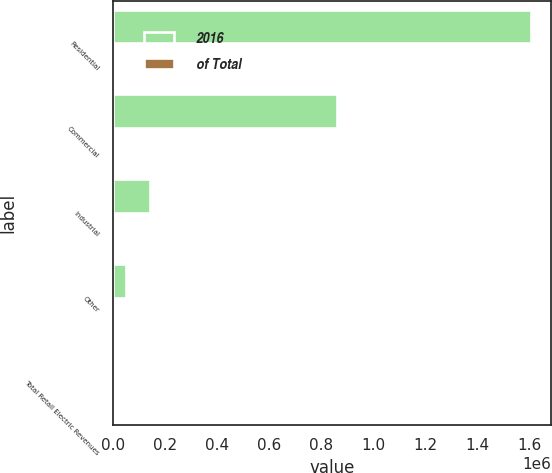Convert chart to OTSL. <chart><loc_0><loc_0><loc_500><loc_500><stacked_bar_chart><ecel><fcel>Residential<fcel>Commercial<fcel>Industrial<fcel>Other<fcel>Total Retail Electric Revenues<nl><fcel>2016<fcel>1.60335e+06<fcel>858965<fcel>139556<fcel>47672<fcel>100<nl><fcel>of Total<fcel>61<fcel>32<fcel>5<fcel>2<fcel>100<nl></chart> 